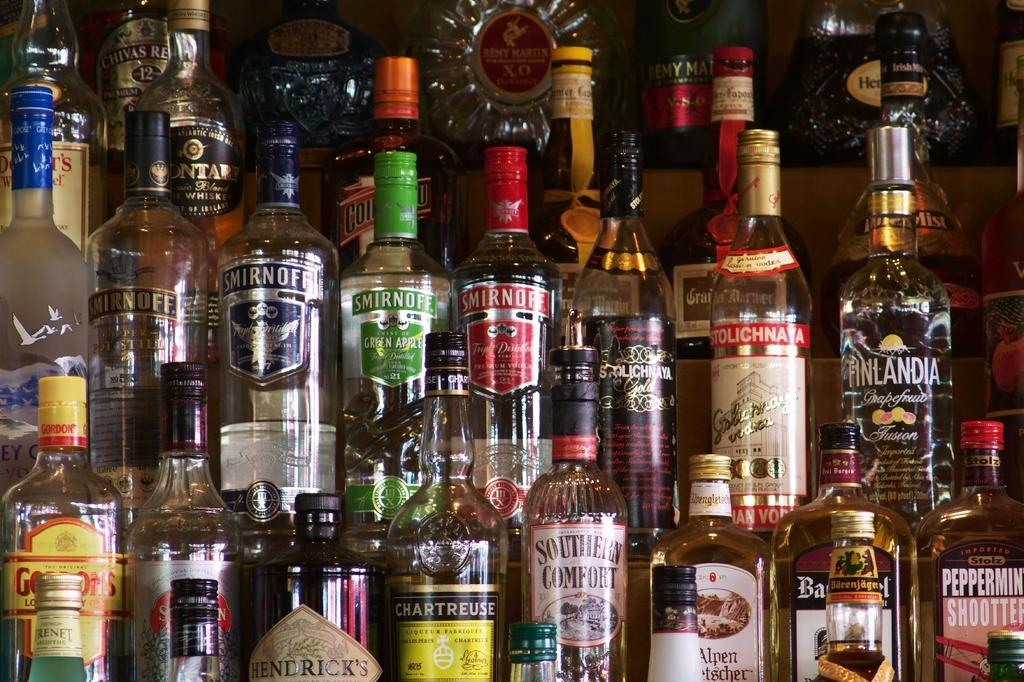<image>
Write a terse but informative summary of the picture. An array of alcohol bottles which includes Smirnoff and Southern Comfort 